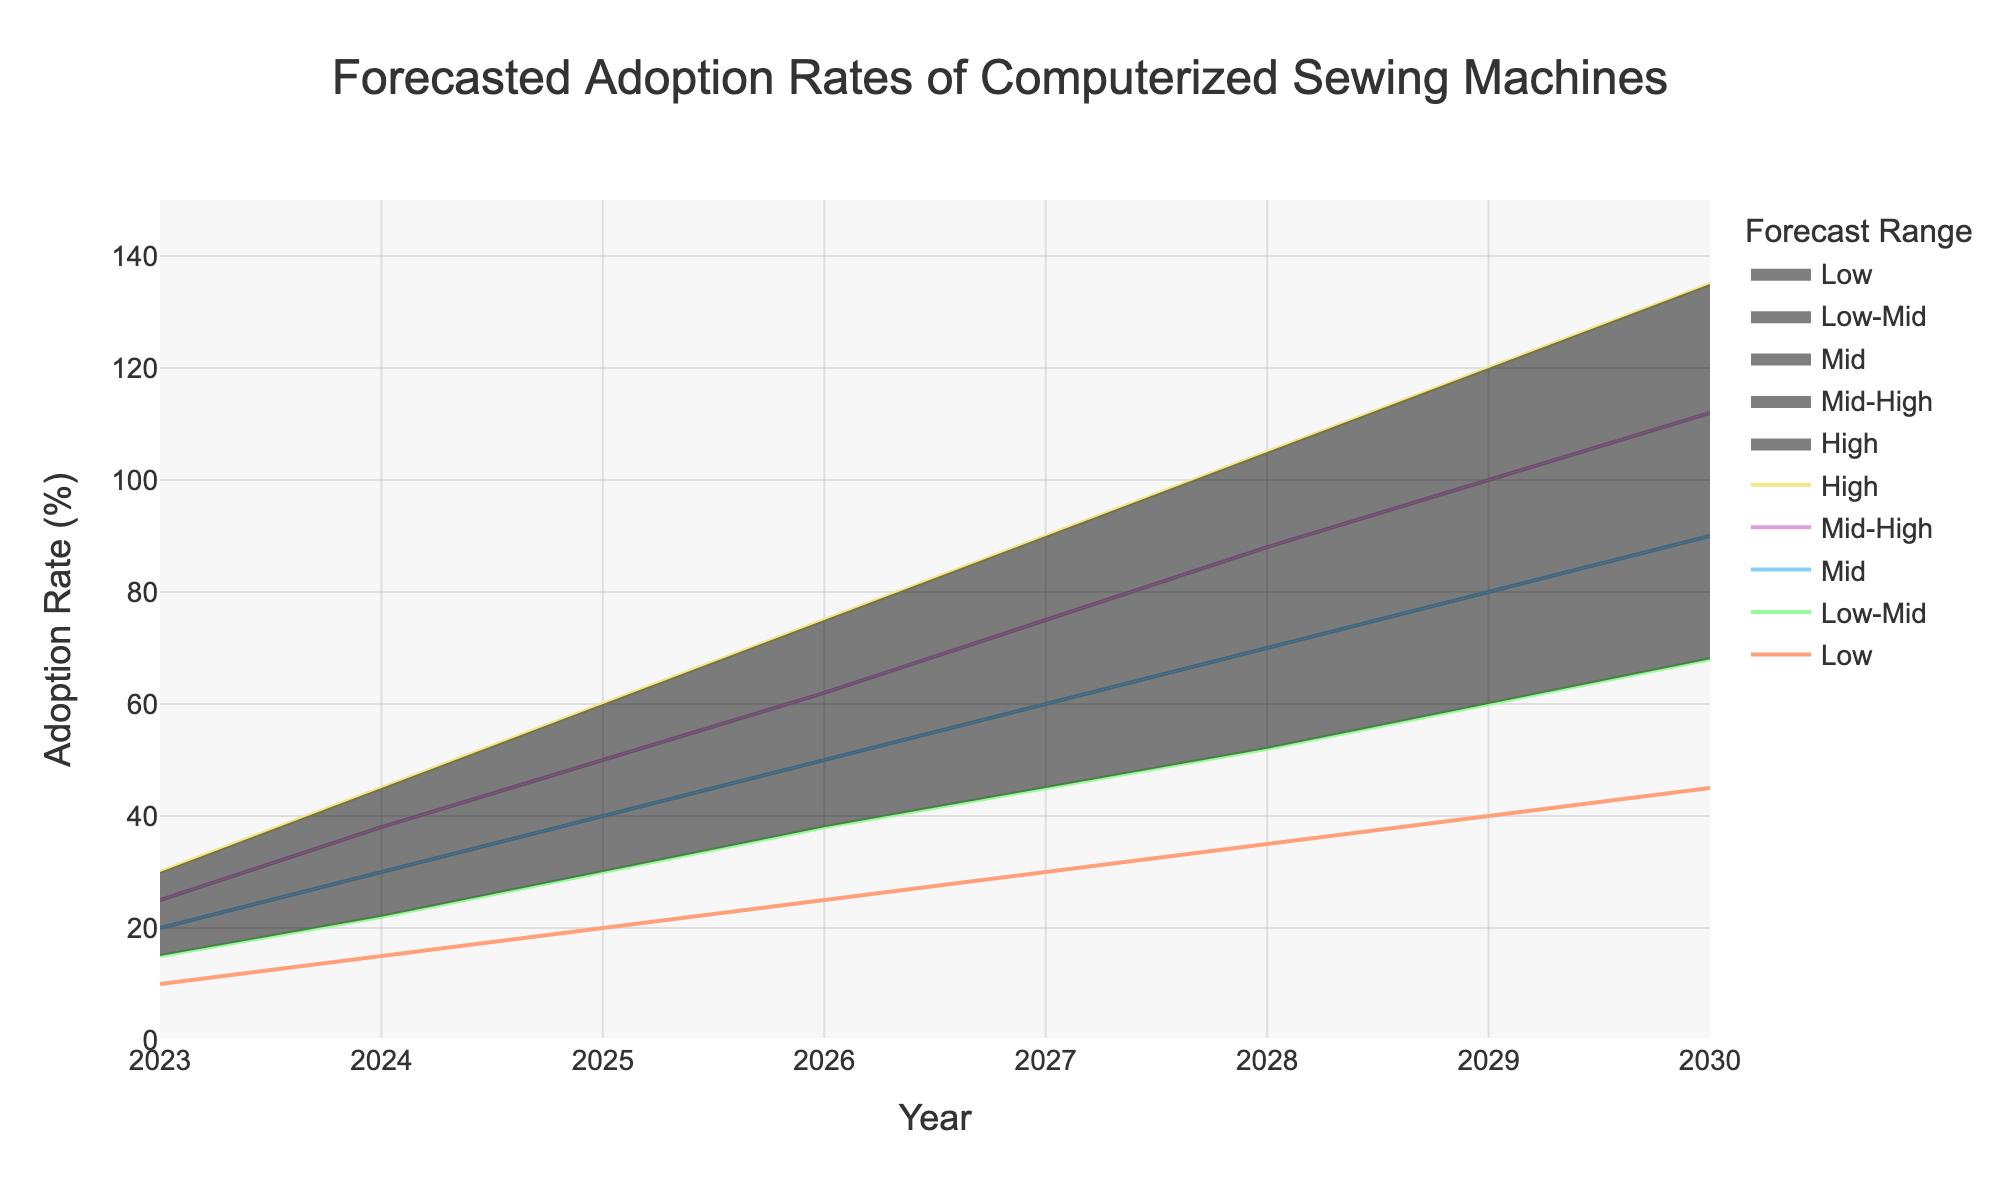what is the title of the figure? The title of the figure is typically displayed at the top center of the chart. For this figure, it is explicitly mentioned in the code that the title is 'Forecasted Adoption Rates of Computerized Sewing Machines'.
Answer: Forecasted Adoption Rates of Computerized Sewing Machines What is the adoption rate range forecasted for the year 2026? To find the adoption rate range for 2026, look at the values of the "Low" and "High" traces for the year 2026. According to the data, the "Low" value is 25% and the "High" value is 75%.
Answer: 25-75% Which year is forecasted to have the highest maximum adoption rate? To determine which year has the highest maximum adoption rate, look for the highest value in the "High" trace. According to the data, this value is 135% in the year 2030.
Answer: 2030 How does the adoption rate in the "Mid" range change from 2023 to 2029? To understand how the "Mid" adoption rate changes from 2023 to 2029, look at the "Mid" values for these years. The value starts at 20% in 2023 and increases to 80% in 2029. The difference is 80% - 20% = 60%.
Answer: Increased by 60% By what percentage does the "Low" adoption rate increase between 2024 and 2028? To find the percentage increase, subtract the "Low" value in 2024 from that in 2028 and divide by the 2024 value, then multiply by 100. The increase is (35 - 15) = 20%. Thus, the percentage increase is (20/15) * 100 = 133.33%.
Answer: 133.33% What is the average forecasted "Mid-High" adoption rate across all years shown? To find the average "Mid-High" adoption rate, sum all the "Mid-High" values for each year and divide by the number of years. Sum = (25+38+50+62+75+88+100+112) = 550. Number of years = 8. Thus, average = 550/8 = 68.75%.
Answer: 68.75% In which year does the "Low-Mid" adoption rate first exceed 50%? To find the year when the "Low-Mid" adoption rate first exceeds 50%, look at the "Low-Mid" values for each year. The value first exceeds 50% in the year 2028 where it reaches 52%.
Answer: 2028 Compare the "Low" adoption rate forecast for 2027 with the "High" adoption rate forecast for 2024. Which is higher and by how much? To compare these rates, find the "Low" value for 2027 (30%) and the "High" value for 2024 (45%). The "High" value for 2024 is higher by 45% - 30% = 15%.
Answer: 2024 "High" by 15% What is the range of the "Mid-High" adoption rate in 2028? To find the range, identify the values at the lower and upper bounds of the "Mid-High" range for 2028. According to the data, the "Mid-High" value for 2028 is 88%. The range is represented by a single value, which is 88%.
Answer: 88% Calculate the yearly increment in the "Mid" adoption rate from 2025 to 2027. To find the yearly increment, look at the "Mid" adoption rates for 2025 (40%), 2026 (50%), and 2027 (60%). The yearly increments are (50-40)=10% for 2025-2026 and (60-50)=10% for 2026-2027.
Answer: 10% per year 